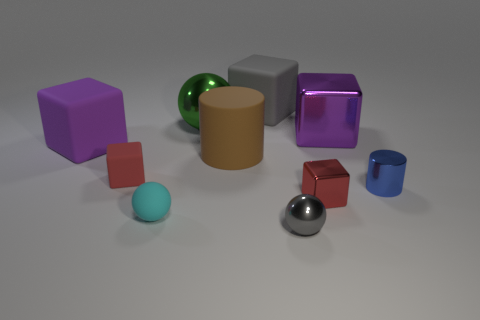Are there any green shiny cubes that have the same size as the brown object? There are no green shiny cubes in the image at all. Instead, there is one green shiny sphere that differs in shape from the brown cylinder. 